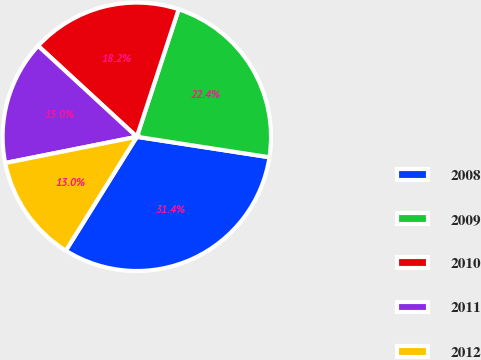Convert chart. <chart><loc_0><loc_0><loc_500><loc_500><pie_chart><fcel>2008<fcel>2009<fcel>2010<fcel>2011<fcel>2012<nl><fcel>31.44%<fcel>22.39%<fcel>18.2%<fcel>14.98%<fcel>12.99%<nl></chart> 